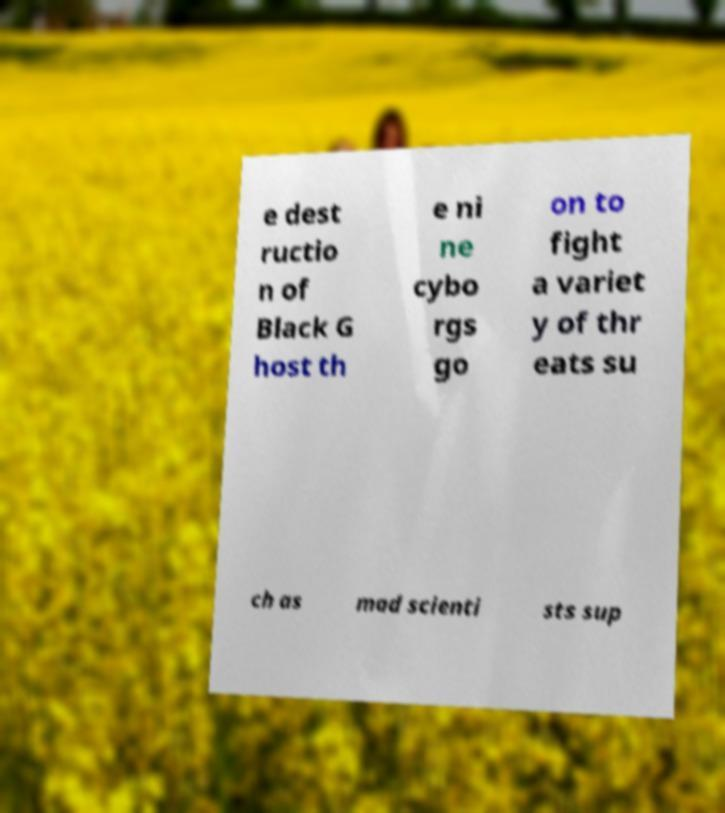There's text embedded in this image that I need extracted. Can you transcribe it verbatim? e dest ructio n of Black G host th e ni ne cybo rgs go on to fight a variet y of thr eats su ch as mad scienti sts sup 